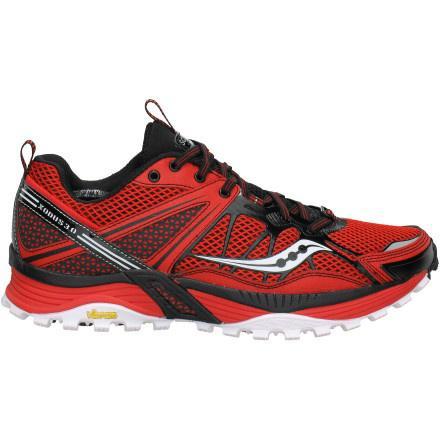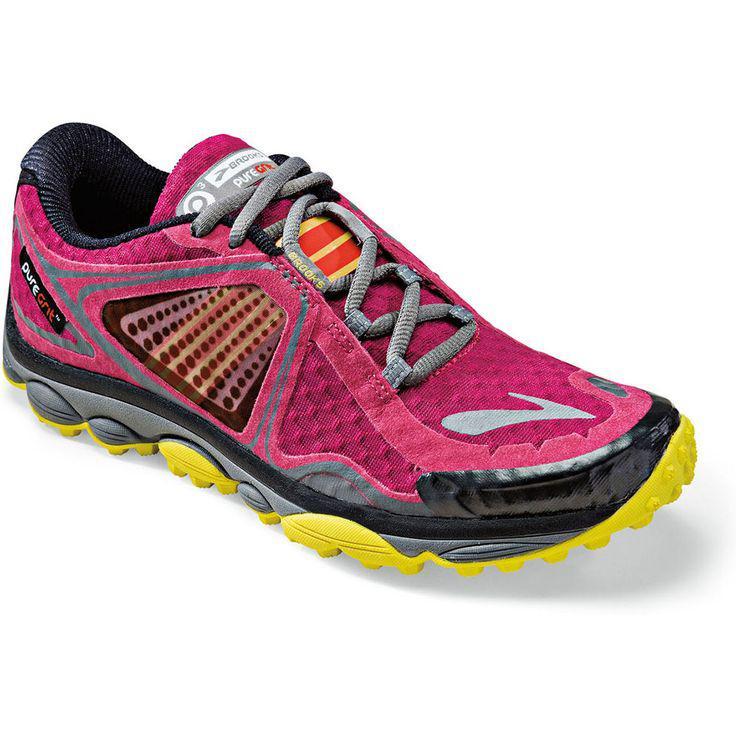The first image is the image on the left, the second image is the image on the right. Considering the images on both sides, is "There is a red shoe with solid black laces." valid? Answer yes or no. Yes. 